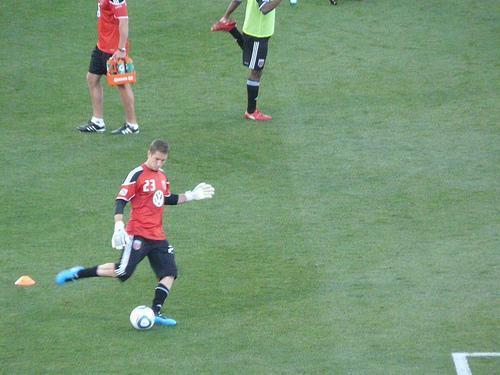How many people are in the picture?
Give a very brief answer. 3. 